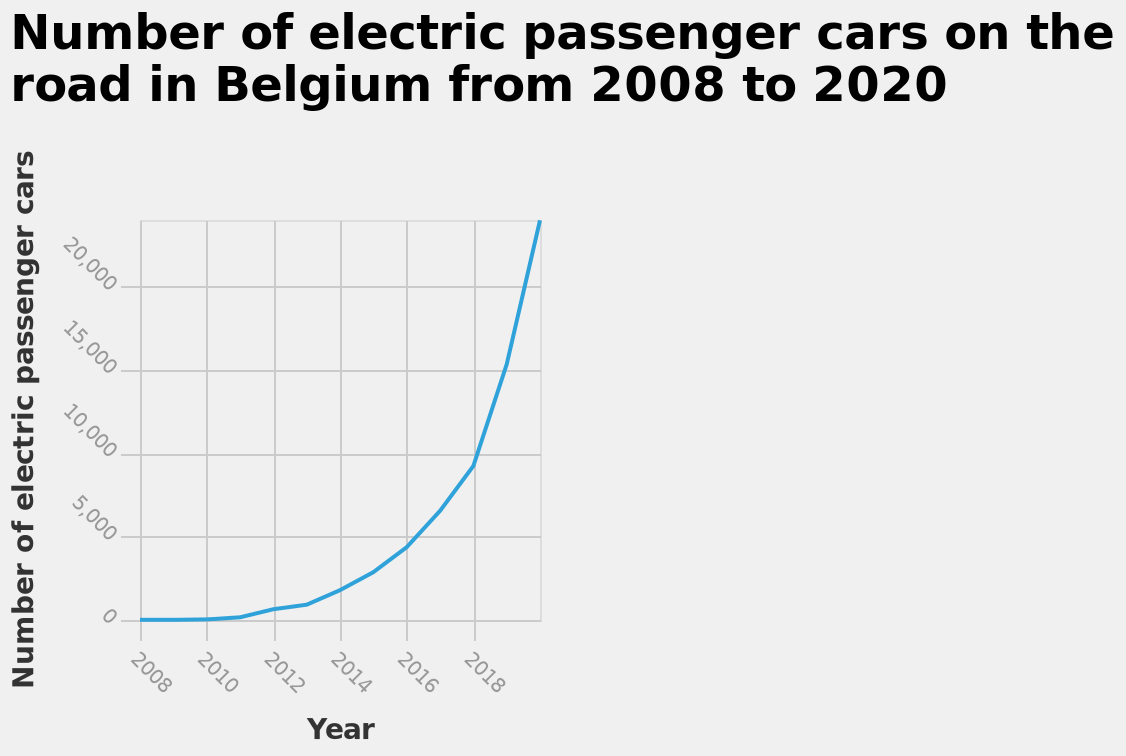<image>
What does the line in the diagram represent? The line in the diagram represents the number of electric passenger cars on the road in Belgium from 2008 to 2020. What is the range of the x-axis in the line diagram? The range of the x-axis in the line diagram is from 2008 to 2018. What was the trend in the number of electric passenger cars in Belgium after 2018? The trend after 2018 showed a significant increase in the number of electric passenger cars on the road in Belgium. 